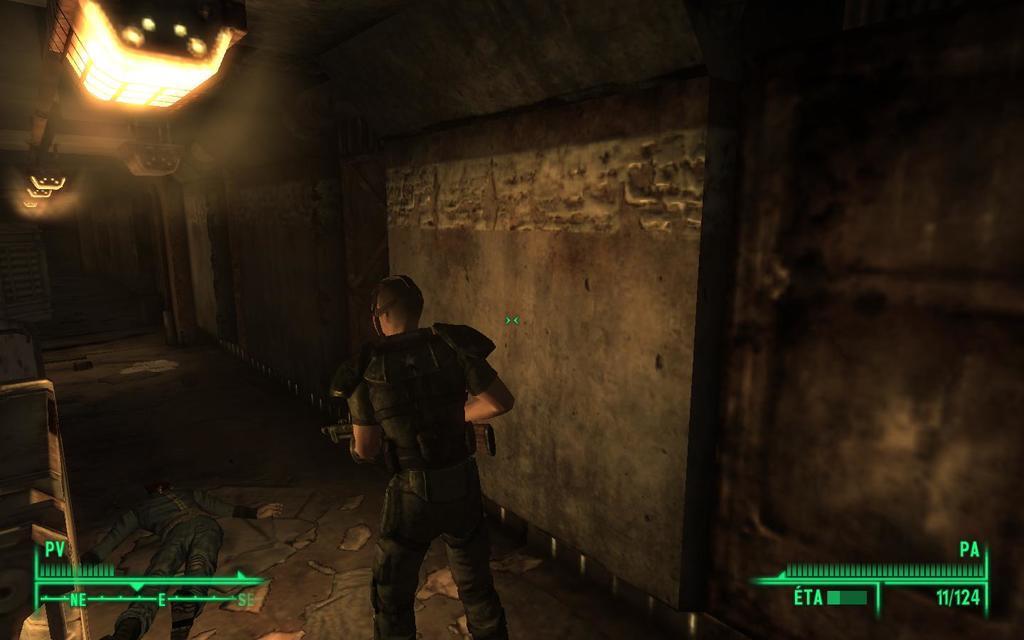Could you give a brief overview of what you see in this image? In this picture we can see symbols and a man holding a gun with his hand and standing on the ground and in front of him we can see a person lying, lights, wall and some objects. 